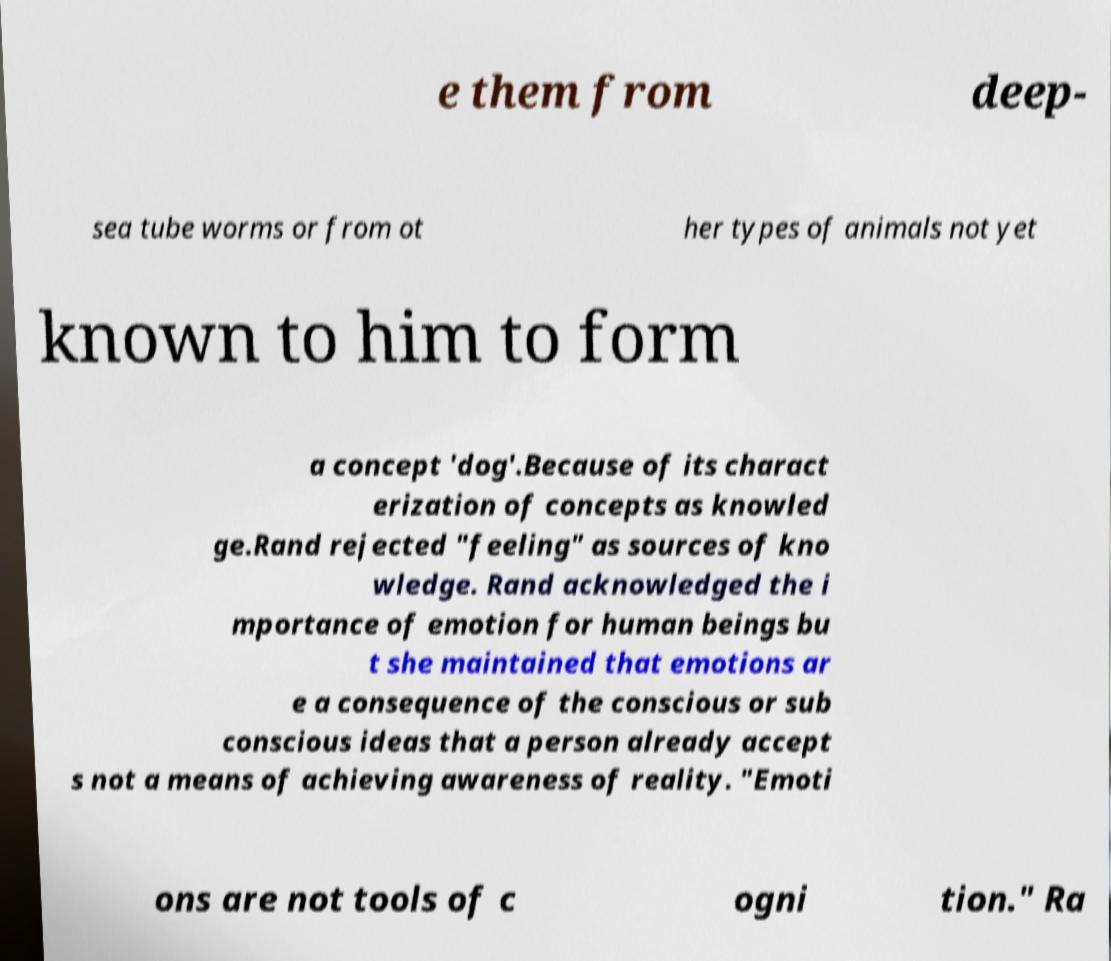Could you extract and type out the text from this image? e them from deep- sea tube worms or from ot her types of animals not yet known to him to form a concept 'dog'.Because of its charact erization of concepts as knowled ge.Rand rejected "feeling" as sources of kno wledge. Rand acknowledged the i mportance of emotion for human beings bu t she maintained that emotions ar e a consequence of the conscious or sub conscious ideas that a person already accept s not a means of achieving awareness of reality. "Emoti ons are not tools of c ogni tion." Ra 